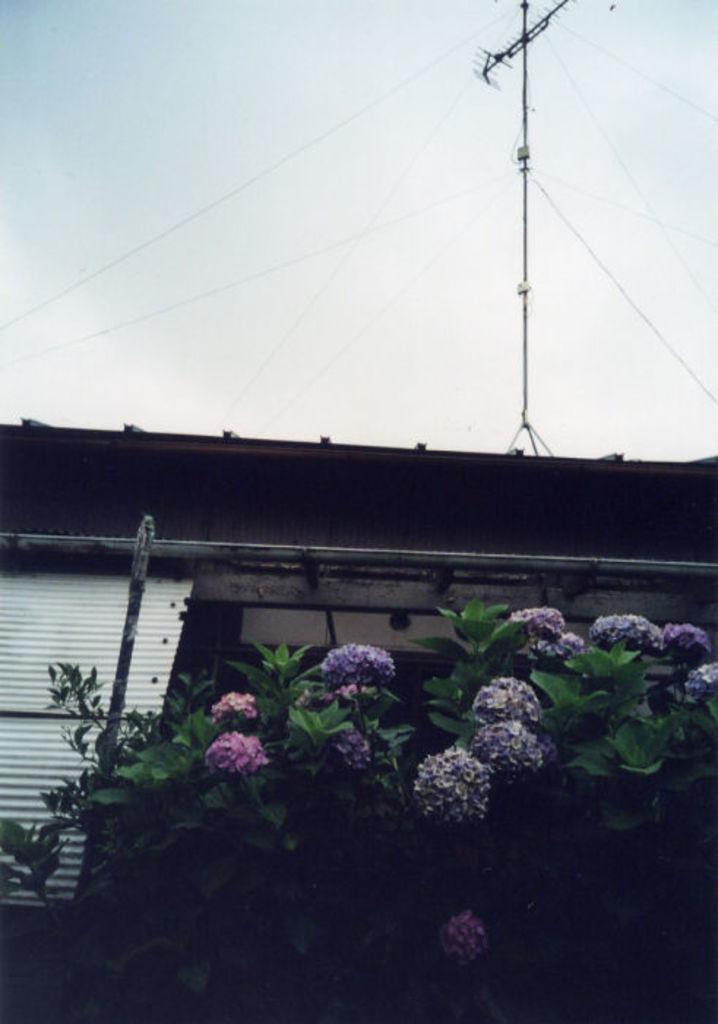Please provide a concise description of this image. In this image I can see few flowers in purple and pink color, plants in green color, a shed in white color. Background I can a current pole and the sky is in white color. 